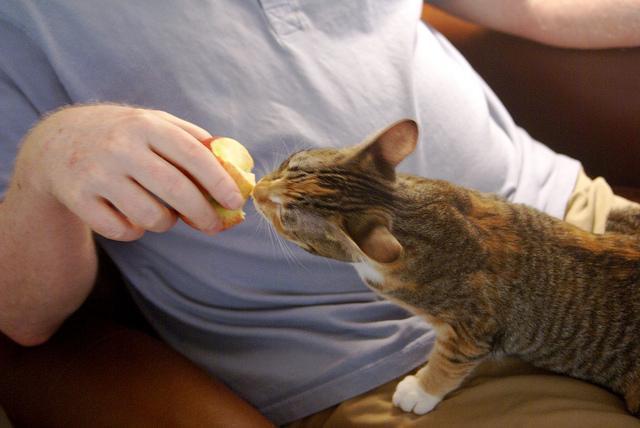Where do apples originate from?
Pick the correct solution from the four options below to address the question.
Options: Australia, europe, england, asia. Asia. 